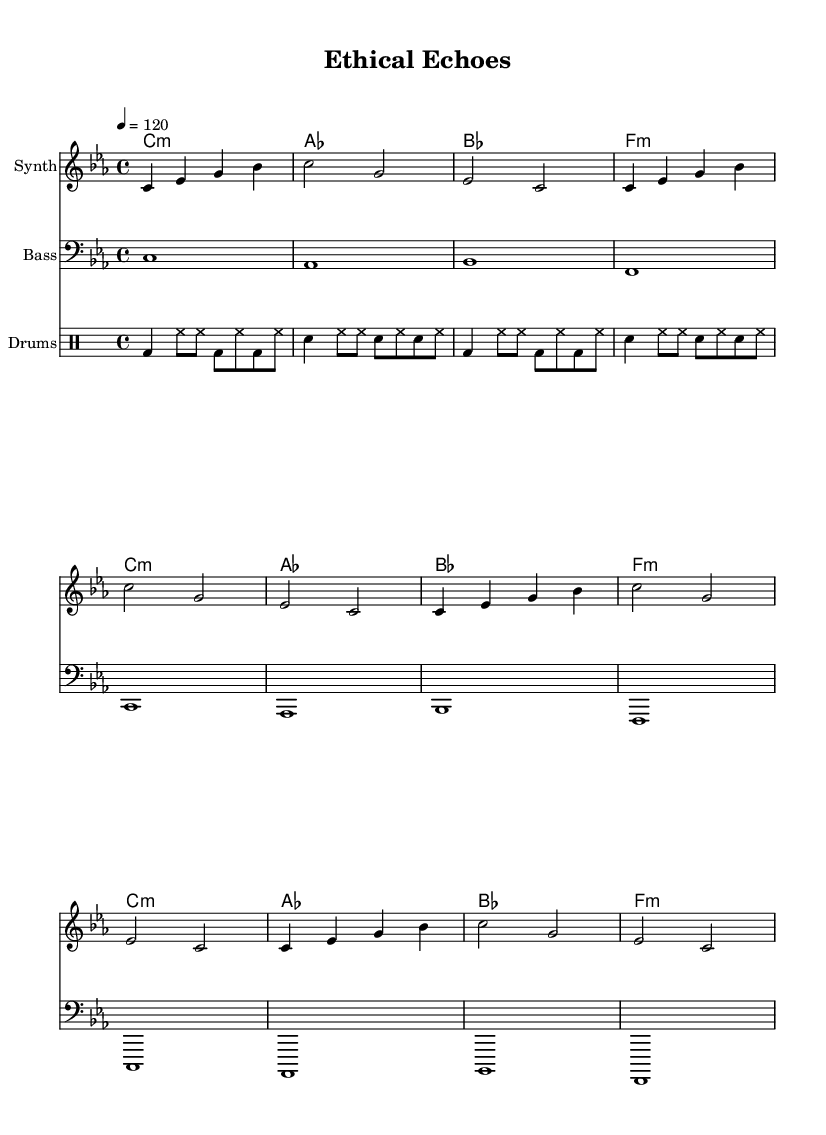What is the key signature of this music? The key signature is indicated at the beginning of the staff and shows three flats, which correspond to the key of C minor.
Answer: C minor What is the time signature of this piece? The time signature at the beginning of the score shows a 4/4 measurement, meaning there are four beats in each measure and the quarter note gets one beat.
Answer: 4/4 What is the tempo marking for this piece? The tempo marking is found at the beginning of the score, showing that the piece should be played at 120 beats per minute.
Answer: 120 How many measures are present in the synth part? The synth part has eight measures as it contains the same music phrase repeated twice, making it easier to count.
Answer: 8 What is the last chord in the chord progression? The last chord in the progression is indicated to be F minor, which is shown at the end of the chord names.
Answer: F:m What percussion instruments are used in this piece? The drum staff indicates the presence of bass drums and snare drums, which are specified in the drum notation.
Answer: Bass and snare What type of piece is this music categorized as? Given the use of synthesizers and spoken word excerpts, this piece is categorized as avant-garde electronic music.
Answer: Avant-garde electronic 